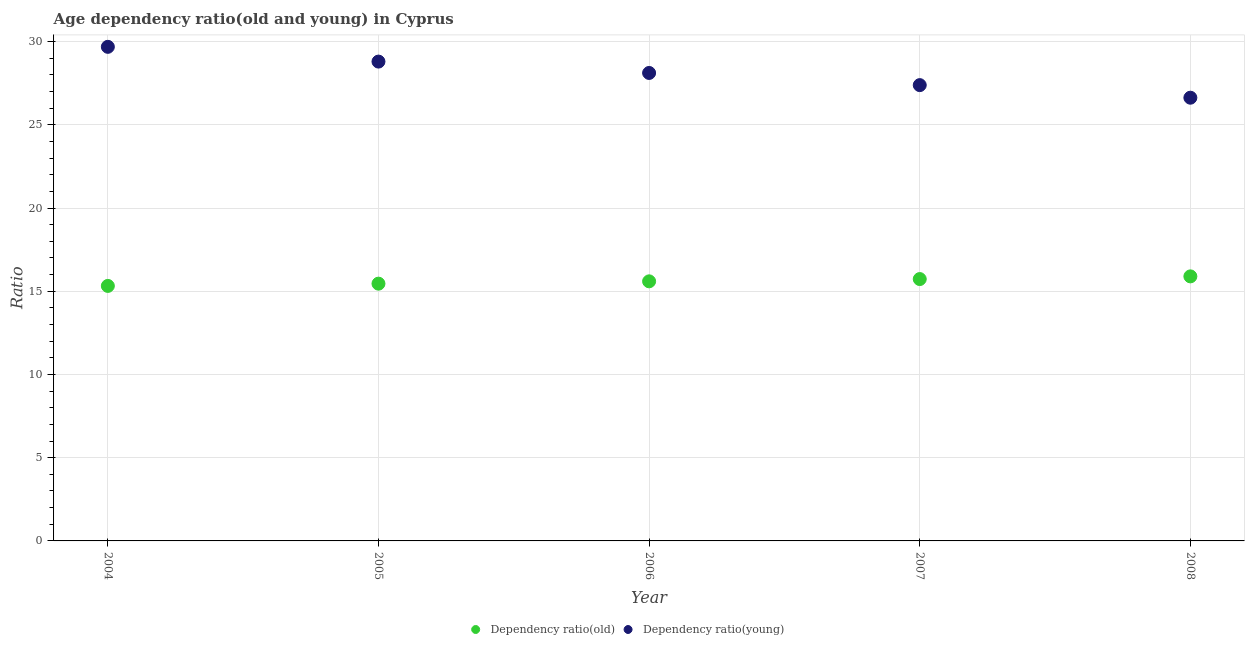Is the number of dotlines equal to the number of legend labels?
Give a very brief answer. Yes. What is the age dependency ratio(young) in 2005?
Your answer should be very brief. 28.8. Across all years, what is the maximum age dependency ratio(old)?
Offer a terse response. 15.89. Across all years, what is the minimum age dependency ratio(old)?
Give a very brief answer. 15.32. In which year was the age dependency ratio(old) maximum?
Offer a very short reply. 2008. In which year was the age dependency ratio(young) minimum?
Ensure brevity in your answer.  2008. What is the total age dependency ratio(old) in the graph?
Offer a very short reply. 77.99. What is the difference between the age dependency ratio(young) in 2005 and that in 2008?
Give a very brief answer. 2.17. What is the difference between the age dependency ratio(young) in 2008 and the age dependency ratio(old) in 2004?
Give a very brief answer. 11.31. What is the average age dependency ratio(young) per year?
Offer a very short reply. 28.12. In the year 2007, what is the difference between the age dependency ratio(old) and age dependency ratio(young)?
Provide a short and direct response. -11.65. In how many years, is the age dependency ratio(old) greater than 4?
Offer a very short reply. 5. What is the ratio of the age dependency ratio(young) in 2005 to that in 2006?
Your answer should be compact. 1.02. Is the age dependency ratio(old) in 2006 less than that in 2007?
Offer a terse response. Yes. Is the difference between the age dependency ratio(old) in 2004 and 2006 greater than the difference between the age dependency ratio(young) in 2004 and 2006?
Ensure brevity in your answer.  No. What is the difference between the highest and the second highest age dependency ratio(old)?
Keep it short and to the point. 0.16. What is the difference between the highest and the lowest age dependency ratio(old)?
Ensure brevity in your answer.  0.57. In how many years, is the age dependency ratio(young) greater than the average age dependency ratio(young) taken over all years?
Your answer should be compact. 2. Is the age dependency ratio(young) strictly greater than the age dependency ratio(old) over the years?
Make the answer very short. Yes. How many years are there in the graph?
Keep it short and to the point. 5. Does the graph contain any zero values?
Ensure brevity in your answer.  No. How are the legend labels stacked?
Provide a succinct answer. Horizontal. What is the title of the graph?
Offer a very short reply. Age dependency ratio(old and young) in Cyprus. What is the label or title of the X-axis?
Offer a terse response. Year. What is the label or title of the Y-axis?
Your answer should be compact. Ratio. What is the Ratio of Dependency ratio(old) in 2004?
Provide a short and direct response. 15.32. What is the Ratio of Dependency ratio(young) in 2004?
Offer a very short reply. 29.68. What is the Ratio of Dependency ratio(old) in 2005?
Give a very brief answer. 15.46. What is the Ratio in Dependency ratio(young) in 2005?
Offer a very short reply. 28.8. What is the Ratio of Dependency ratio(old) in 2006?
Give a very brief answer. 15.6. What is the Ratio in Dependency ratio(young) in 2006?
Your answer should be compact. 28.11. What is the Ratio in Dependency ratio(old) in 2007?
Offer a very short reply. 15.73. What is the Ratio of Dependency ratio(young) in 2007?
Offer a very short reply. 27.38. What is the Ratio of Dependency ratio(old) in 2008?
Offer a terse response. 15.89. What is the Ratio of Dependency ratio(young) in 2008?
Give a very brief answer. 26.63. Across all years, what is the maximum Ratio in Dependency ratio(old)?
Offer a terse response. 15.89. Across all years, what is the maximum Ratio in Dependency ratio(young)?
Provide a succinct answer. 29.68. Across all years, what is the minimum Ratio of Dependency ratio(old)?
Provide a short and direct response. 15.32. Across all years, what is the minimum Ratio of Dependency ratio(young)?
Keep it short and to the point. 26.63. What is the total Ratio of Dependency ratio(old) in the graph?
Your response must be concise. 77.99. What is the total Ratio of Dependency ratio(young) in the graph?
Your answer should be very brief. 140.6. What is the difference between the Ratio of Dependency ratio(old) in 2004 and that in 2005?
Make the answer very short. -0.14. What is the difference between the Ratio in Dependency ratio(young) in 2004 and that in 2005?
Your answer should be very brief. 0.89. What is the difference between the Ratio in Dependency ratio(old) in 2004 and that in 2006?
Ensure brevity in your answer.  -0.28. What is the difference between the Ratio in Dependency ratio(young) in 2004 and that in 2006?
Offer a very short reply. 1.57. What is the difference between the Ratio in Dependency ratio(old) in 2004 and that in 2007?
Ensure brevity in your answer.  -0.41. What is the difference between the Ratio of Dependency ratio(young) in 2004 and that in 2007?
Your response must be concise. 2.3. What is the difference between the Ratio of Dependency ratio(old) in 2004 and that in 2008?
Provide a succinct answer. -0.57. What is the difference between the Ratio in Dependency ratio(young) in 2004 and that in 2008?
Offer a terse response. 3.06. What is the difference between the Ratio of Dependency ratio(old) in 2005 and that in 2006?
Provide a succinct answer. -0.14. What is the difference between the Ratio in Dependency ratio(young) in 2005 and that in 2006?
Make the answer very short. 0.68. What is the difference between the Ratio in Dependency ratio(old) in 2005 and that in 2007?
Offer a very short reply. -0.28. What is the difference between the Ratio of Dependency ratio(young) in 2005 and that in 2007?
Provide a succinct answer. 1.41. What is the difference between the Ratio of Dependency ratio(old) in 2005 and that in 2008?
Ensure brevity in your answer.  -0.44. What is the difference between the Ratio in Dependency ratio(young) in 2005 and that in 2008?
Your answer should be very brief. 2.17. What is the difference between the Ratio in Dependency ratio(old) in 2006 and that in 2007?
Provide a short and direct response. -0.14. What is the difference between the Ratio of Dependency ratio(young) in 2006 and that in 2007?
Make the answer very short. 0.73. What is the difference between the Ratio in Dependency ratio(old) in 2006 and that in 2008?
Your answer should be very brief. -0.3. What is the difference between the Ratio of Dependency ratio(young) in 2006 and that in 2008?
Give a very brief answer. 1.49. What is the difference between the Ratio in Dependency ratio(old) in 2007 and that in 2008?
Provide a short and direct response. -0.16. What is the difference between the Ratio in Dependency ratio(young) in 2007 and that in 2008?
Offer a very short reply. 0.76. What is the difference between the Ratio of Dependency ratio(old) in 2004 and the Ratio of Dependency ratio(young) in 2005?
Your answer should be compact. -13.48. What is the difference between the Ratio in Dependency ratio(old) in 2004 and the Ratio in Dependency ratio(young) in 2006?
Your answer should be compact. -12.79. What is the difference between the Ratio in Dependency ratio(old) in 2004 and the Ratio in Dependency ratio(young) in 2007?
Make the answer very short. -12.06. What is the difference between the Ratio in Dependency ratio(old) in 2004 and the Ratio in Dependency ratio(young) in 2008?
Keep it short and to the point. -11.31. What is the difference between the Ratio of Dependency ratio(old) in 2005 and the Ratio of Dependency ratio(young) in 2006?
Give a very brief answer. -12.66. What is the difference between the Ratio in Dependency ratio(old) in 2005 and the Ratio in Dependency ratio(young) in 2007?
Your response must be concise. -11.93. What is the difference between the Ratio of Dependency ratio(old) in 2005 and the Ratio of Dependency ratio(young) in 2008?
Make the answer very short. -11.17. What is the difference between the Ratio of Dependency ratio(old) in 2006 and the Ratio of Dependency ratio(young) in 2007?
Make the answer very short. -11.79. What is the difference between the Ratio of Dependency ratio(old) in 2006 and the Ratio of Dependency ratio(young) in 2008?
Make the answer very short. -11.03. What is the difference between the Ratio in Dependency ratio(old) in 2007 and the Ratio in Dependency ratio(young) in 2008?
Ensure brevity in your answer.  -10.9. What is the average Ratio in Dependency ratio(old) per year?
Your response must be concise. 15.6. What is the average Ratio in Dependency ratio(young) per year?
Your response must be concise. 28.12. In the year 2004, what is the difference between the Ratio in Dependency ratio(old) and Ratio in Dependency ratio(young)?
Make the answer very short. -14.36. In the year 2005, what is the difference between the Ratio in Dependency ratio(old) and Ratio in Dependency ratio(young)?
Offer a very short reply. -13.34. In the year 2006, what is the difference between the Ratio of Dependency ratio(old) and Ratio of Dependency ratio(young)?
Keep it short and to the point. -12.52. In the year 2007, what is the difference between the Ratio of Dependency ratio(old) and Ratio of Dependency ratio(young)?
Keep it short and to the point. -11.65. In the year 2008, what is the difference between the Ratio of Dependency ratio(old) and Ratio of Dependency ratio(young)?
Ensure brevity in your answer.  -10.73. What is the ratio of the Ratio of Dependency ratio(old) in 2004 to that in 2005?
Keep it short and to the point. 0.99. What is the ratio of the Ratio of Dependency ratio(young) in 2004 to that in 2005?
Make the answer very short. 1.03. What is the ratio of the Ratio in Dependency ratio(old) in 2004 to that in 2006?
Your response must be concise. 0.98. What is the ratio of the Ratio in Dependency ratio(young) in 2004 to that in 2006?
Offer a terse response. 1.06. What is the ratio of the Ratio in Dependency ratio(old) in 2004 to that in 2007?
Make the answer very short. 0.97. What is the ratio of the Ratio of Dependency ratio(young) in 2004 to that in 2007?
Your answer should be very brief. 1.08. What is the ratio of the Ratio of Dependency ratio(old) in 2004 to that in 2008?
Provide a succinct answer. 0.96. What is the ratio of the Ratio in Dependency ratio(young) in 2004 to that in 2008?
Make the answer very short. 1.11. What is the ratio of the Ratio of Dependency ratio(young) in 2005 to that in 2006?
Offer a terse response. 1.02. What is the ratio of the Ratio of Dependency ratio(old) in 2005 to that in 2007?
Ensure brevity in your answer.  0.98. What is the ratio of the Ratio of Dependency ratio(young) in 2005 to that in 2007?
Give a very brief answer. 1.05. What is the ratio of the Ratio in Dependency ratio(old) in 2005 to that in 2008?
Provide a short and direct response. 0.97. What is the ratio of the Ratio of Dependency ratio(young) in 2005 to that in 2008?
Keep it short and to the point. 1.08. What is the ratio of the Ratio of Dependency ratio(old) in 2006 to that in 2007?
Ensure brevity in your answer.  0.99. What is the ratio of the Ratio of Dependency ratio(young) in 2006 to that in 2007?
Give a very brief answer. 1.03. What is the ratio of the Ratio in Dependency ratio(old) in 2006 to that in 2008?
Provide a succinct answer. 0.98. What is the ratio of the Ratio of Dependency ratio(young) in 2006 to that in 2008?
Provide a short and direct response. 1.06. What is the ratio of the Ratio in Dependency ratio(old) in 2007 to that in 2008?
Keep it short and to the point. 0.99. What is the ratio of the Ratio in Dependency ratio(young) in 2007 to that in 2008?
Offer a terse response. 1.03. What is the difference between the highest and the second highest Ratio of Dependency ratio(old)?
Give a very brief answer. 0.16. What is the difference between the highest and the second highest Ratio in Dependency ratio(young)?
Provide a succinct answer. 0.89. What is the difference between the highest and the lowest Ratio in Dependency ratio(old)?
Provide a short and direct response. 0.57. What is the difference between the highest and the lowest Ratio of Dependency ratio(young)?
Provide a succinct answer. 3.06. 